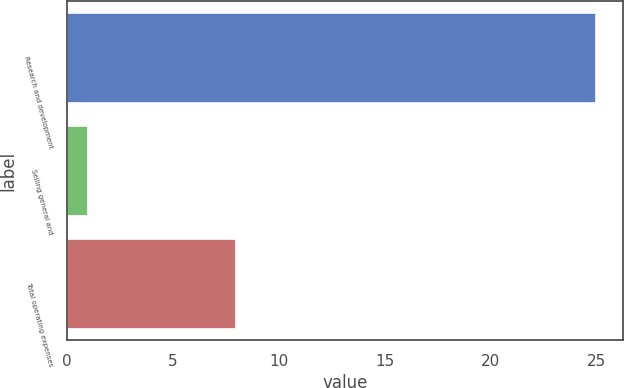Convert chart. <chart><loc_0><loc_0><loc_500><loc_500><bar_chart><fcel>Research and development<fcel>Selling general and<fcel>Total operating expenses<nl><fcel>25<fcel>1<fcel>8<nl></chart> 